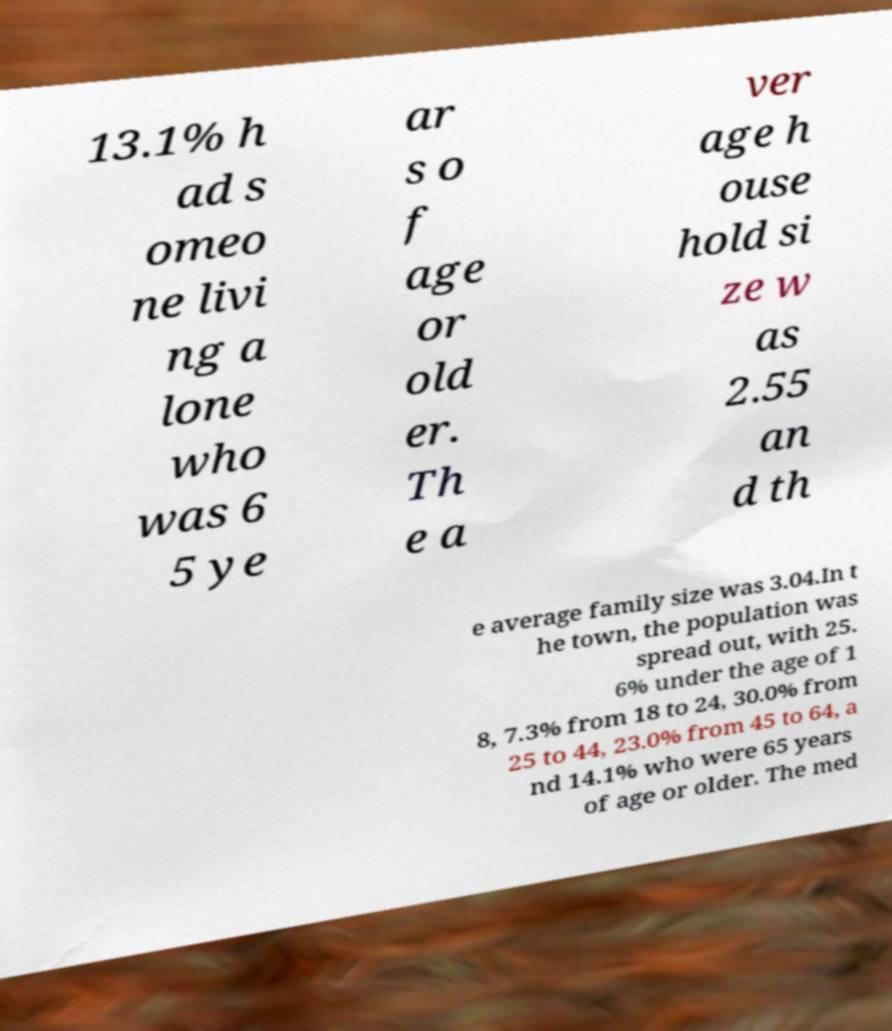For documentation purposes, I need the text within this image transcribed. Could you provide that? 13.1% h ad s omeo ne livi ng a lone who was 6 5 ye ar s o f age or old er. Th e a ver age h ouse hold si ze w as 2.55 an d th e average family size was 3.04.In t he town, the population was spread out, with 25. 6% under the age of 1 8, 7.3% from 18 to 24, 30.0% from 25 to 44, 23.0% from 45 to 64, a nd 14.1% who were 65 years of age or older. The med 